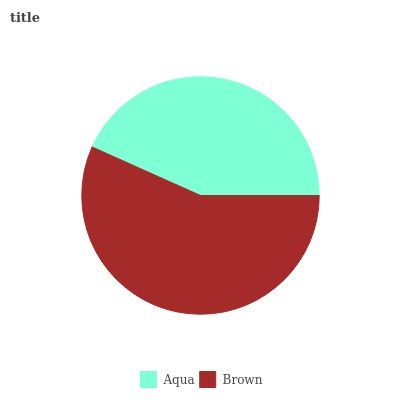Is Aqua the minimum?
Answer yes or no. Yes. Is Brown the maximum?
Answer yes or no. Yes. Is Brown the minimum?
Answer yes or no. No. Is Brown greater than Aqua?
Answer yes or no. Yes. Is Aqua less than Brown?
Answer yes or no. Yes. Is Aqua greater than Brown?
Answer yes or no. No. Is Brown less than Aqua?
Answer yes or no. No. Is Brown the high median?
Answer yes or no. Yes. Is Aqua the low median?
Answer yes or no. Yes. Is Aqua the high median?
Answer yes or no. No. Is Brown the low median?
Answer yes or no. No. 